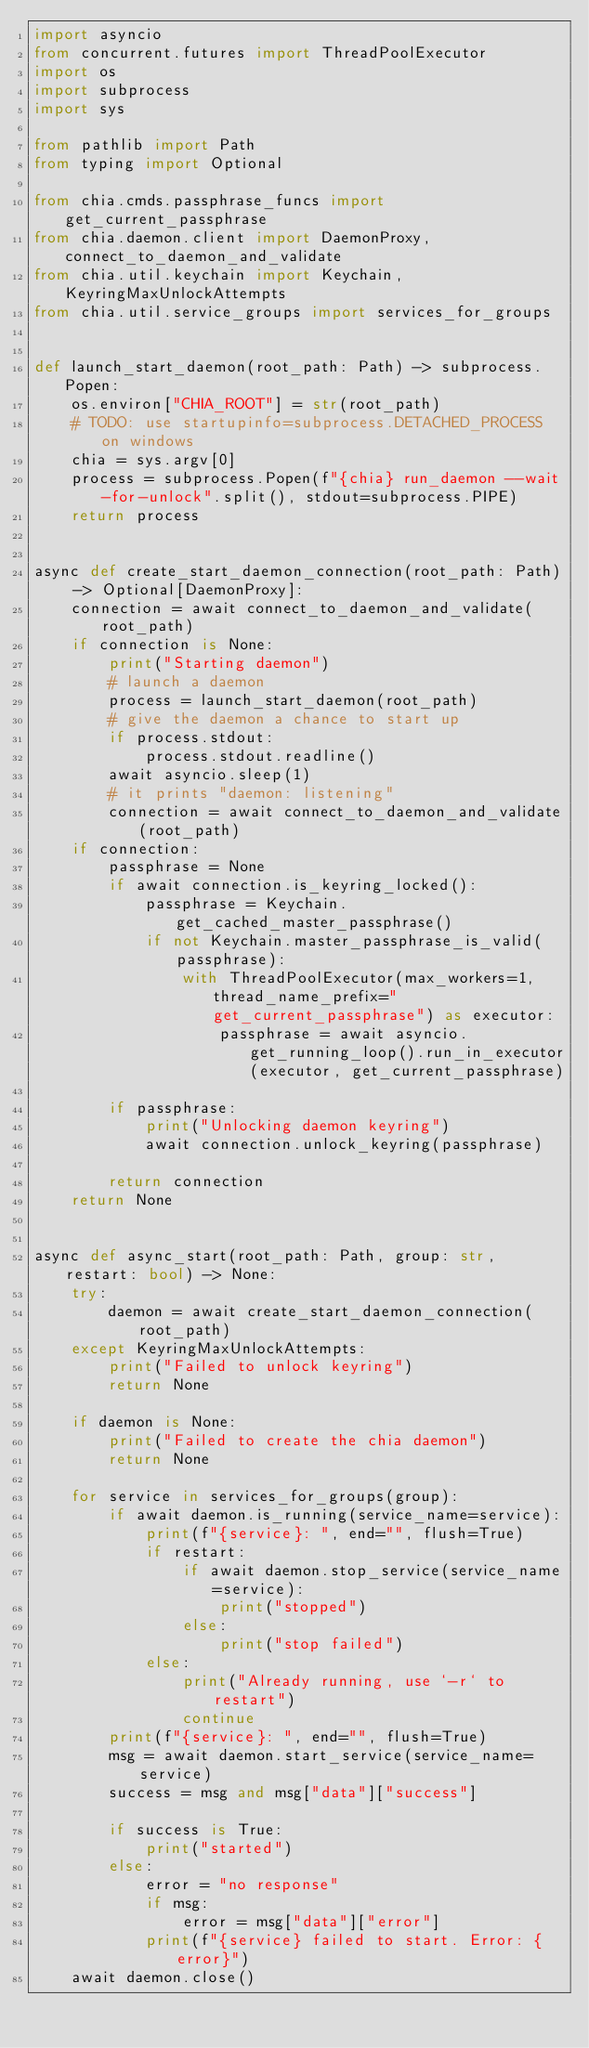<code> <loc_0><loc_0><loc_500><loc_500><_Python_>import asyncio
from concurrent.futures import ThreadPoolExecutor
import os
import subprocess
import sys

from pathlib import Path
from typing import Optional

from chia.cmds.passphrase_funcs import get_current_passphrase
from chia.daemon.client import DaemonProxy, connect_to_daemon_and_validate
from chia.util.keychain import Keychain, KeyringMaxUnlockAttempts
from chia.util.service_groups import services_for_groups


def launch_start_daemon(root_path: Path) -> subprocess.Popen:
    os.environ["CHIA_ROOT"] = str(root_path)
    # TODO: use startupinfo=subprocess.DETACHED_PROCESS on windows
    chia = sys.argv[0]
    process = subprocess.Popen(f"{chia} run_daemon --wait-for-unlock".split(), stdout=subprocess.PIPE)
    return process


async def create_start_daemon_connection(root_path: Path) -> Optional[DaemonProxy]:
    connection = await connect_to_daemon_and_validate(root_path)
    if connection is None:
        print("Starting daemon")
        # launch a daemon
        process = launch_start_daemon(root_path)
        # give the daemon a chance to start up
        if process.stdout:
            process.stdout.readline()
        await asyncio.sleep(1)
        # it prints "daemon: listening"
        connection = await connect_to_daemon_and_validate(root_path)
    if connection:
        passphrase = None
        if await connection.is_keyring_locked():
            passphrase = Keychain.get_cached_master_passphrase()
            if not Keychain.master_passphrase_is_valid(passphrase):
                with ThreadPoolExecutor(max_workers=1, thread_name_prefix="get_current_passphrase") as executor:
                    passphrase = await asyncio.get_running_loop().run_in_executor(executor, get_current_passphrase)

        if passphrase:
            print("Unlocking daemon keyring")
            await connection.unlock_keyring(passphrase)

        return connection
    return None


async def async_start(root_path: Path, group: str, restart: bool) -> None:
    try:
        daemon = await create_start_daemon_connection(root_path)
    except KeyringMaxUnlockAttempts:
        print("Failed to unlock keyring")
        return None

    if daemon is None:
        print("Failed to create the chia daemon")
        return None

    for service in services_for_groups(group):
        if await daemon.is_running(service_name=service):
            print(f"{service}: ", end="", flush=True)
            if restart:
                if await daemon.stop_service(service_name=service):
                    print("stopped")
                else:
                    print("stop failed")
            else:
                print("Already running, use `-r` to restart")
                continue
        print(f"{service}: ", end="", flush=True)
        msg = await daemon.start_service(service_name=service)
        success = msg and msg["data"]["success"]

        if success is True:
            print("started")
        else:
            error = "no response"
            if msg:
                error = msg["data"]["error"]
            print(f"{service} failed to start. Error: {error}")
    await daemon.close()
</code> 